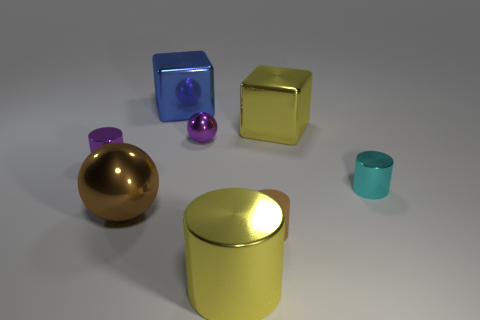Subtract all yellow cylinders. How many cylinders are left? 3 Add 2 tiny gray metallic things. How many objects exist? 10 Subtract all yellow cubes. How many cubes are left? 1 Subtract all cubes. How many objects are left? 6 Subtract all red cubes. Subtract all blue spheres. How many cubes are left? 2 Subtract all big brown metallic objects. Subtract all yellow blocks. How many objects are left? 6 Add 5 tiny purple metallic things. How many tiny purple metallic things are left? 7 Add 2 small metal cylinders. How many small metal cylinders exist? 4 Subtract 0 brown cubes. How many objects are left? 8 Subtract 1 balls. How many balls are left? 1 